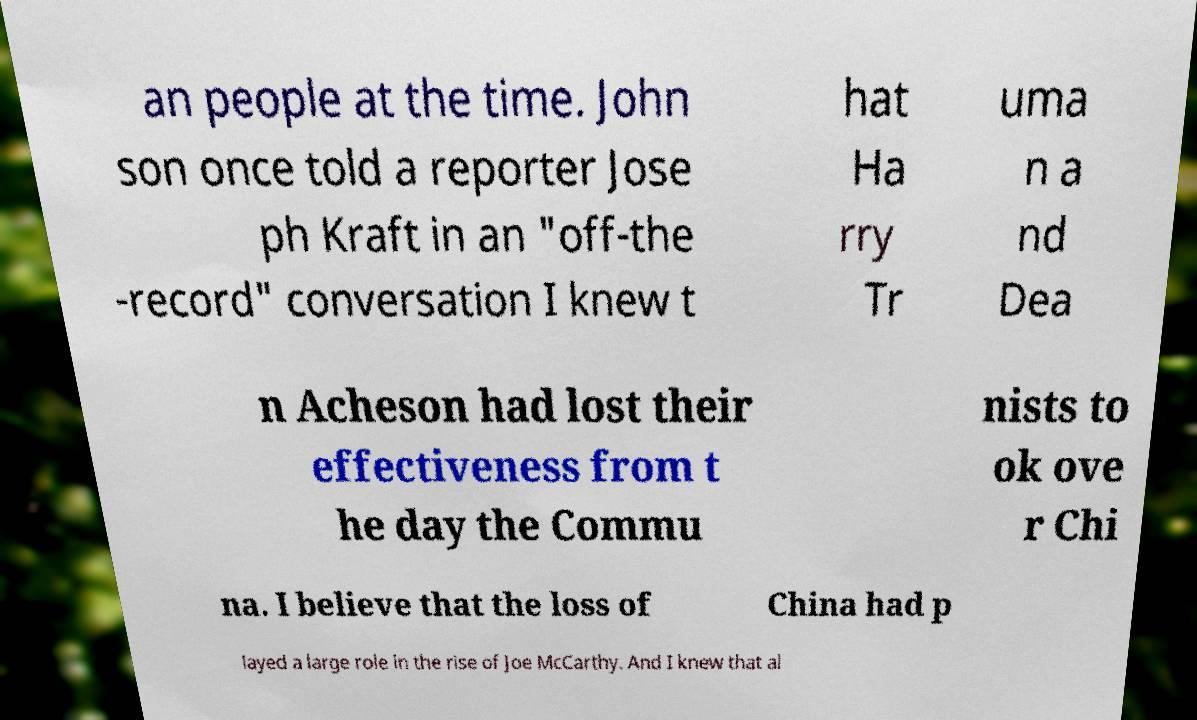For documentation purposes, I need the text within this image transcribed. Could you provide that? an people at the time. John son once told a reporter Jose ph Kraft in an "off-the -record" conversation I knew t hat Ha rry Tr uma n a nd Dea n Acheson had lost their effectiveness from t he day the Commu nists to ok ove r Chi na. I believe that the loss of China had p layed a large role in the rise of Joe McCarthy. And I knew that al 